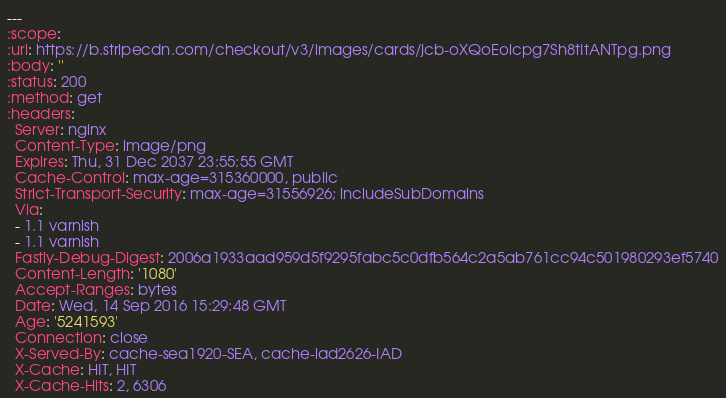Convert code to text. <code><loc_0><loc_0><loc_500><loc_500><_YAML_>---
:scope: 
:url: https://b.stripecdn.com/checkout/v3/images/cards/jcb-oXQoEoicpg7Sh8tItANTpg.png
:body: ''
:status: 200
:method: get
:headers:
  Server: nginx
  Content-Type: image/png
  Expires: Thu, 31 Dec 2037 23:55:55 GMT
  Cache-Control: max-age=315360000, public
  Strict-Transport-Security: max-age=31556926; includeSubDomains
  Via:
  - 1.1 varnish
  - 1.1 varnish
  Fastly-Debug-Digest: 2006a1933aad959d5f9295fabc5c0dfb564c2a5ab761cc94c501980293ef5740
  Content-Length: '1080'
  Accept-Ranges: bytes
  Date: Wed, 14 Sep 2016 15:29:48 GMT
  Age: '5241593'
  Connection: close
  X-Served-By: cache-sea1920-SEA, cache-iad2626-IAD
  X-Cache: HIT, HIT
  X-Cache-Hits: 2, 6306</code> 